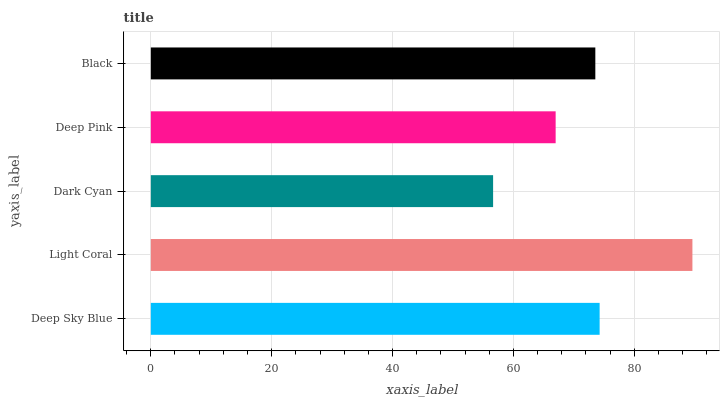Is Dark Cyan the minimum?
Answer yes or no. Yes. Is Light Coral the maximum?
Answer yes or no. Yes. Is Light Coral the minimum?
Answer yes or no. No. Is Dark Cyan the maximum?
Answer yes or no. No. Is Light Coral greater than Dark Cyan?
Answer yes or no. Yes. Is Dark Cyan less than Light Coral?
Answer yes or no. Yes. Is Dark Cyan greater than Light Coral?
Answer yes or no. No. Is Light Coral less than Dark Cyan?
Answer yes or no. No. Is Black the high median?
Answer yes or no. Yes. Is Black the low median?
Answer yes or no. Yes. Is Dark Cyan the high median?
Answer yes or no. No. Is Deep Pink the low median?
Answer yes or no. No. 